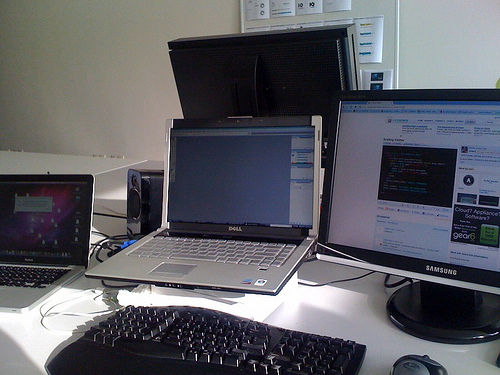Read and extract the text from this image. Bears SAMSUNG 